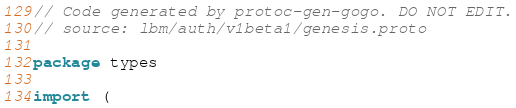Convert code to text. <code><loc_0><loc_0><loc_500><loc_500><_Go_>// Code generated by protoc-gen-gogo. DO NOT EDIT.
// source: lbm/auth/v1beta1/genesis.proto

package types

import (</code> 